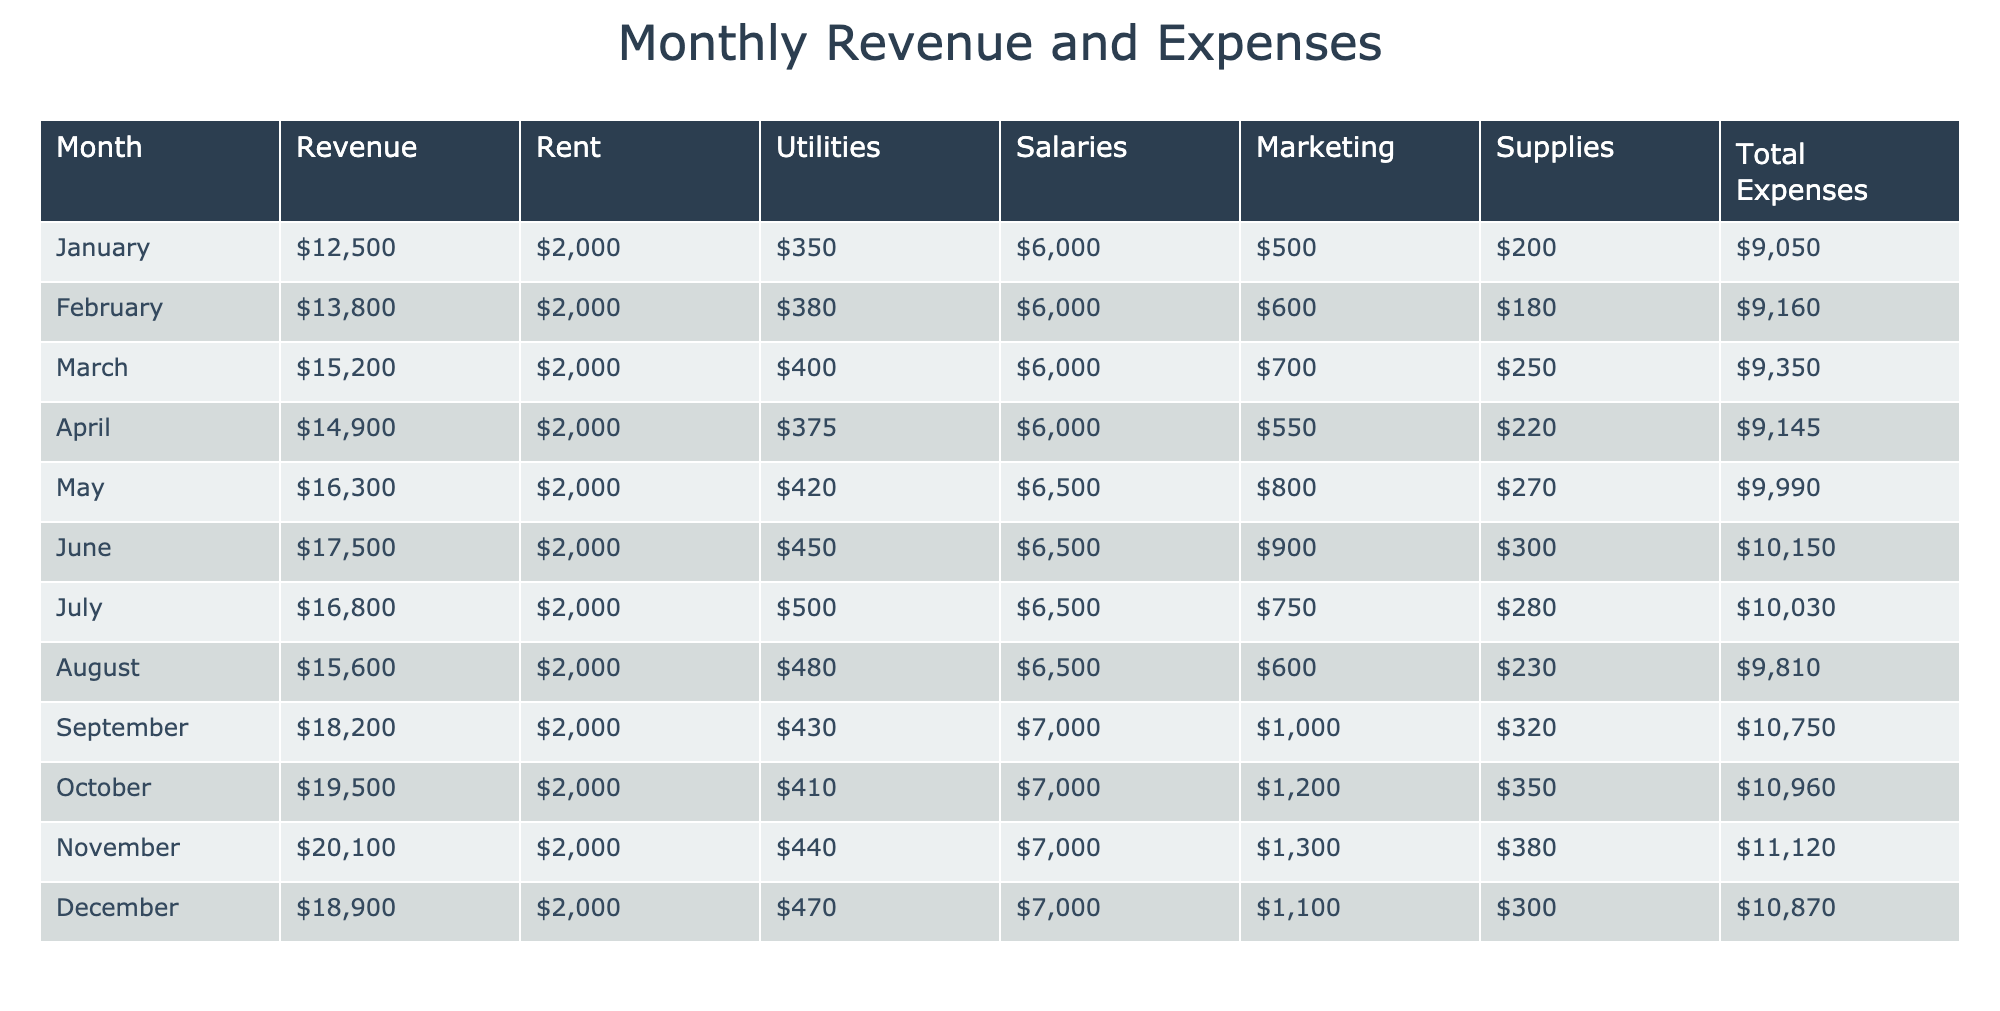What was the total revenue for April? In the table, I can locate the row for April, where the revenue amount is shown. According to the data presented, the total revenue for April is listed as $14,900.
Answer: $14,900 What are the total expenses for the counseling center in February? By examining the row for February, I find that the total expenses are provided directly. The total expenses for February are noted as $9,160.
Answer: $9,160 Which month had the highest revenue, and what was that amount? I can review each row to find the highest revenue figure. Scanning through the revenues listed from January to December, I see that December has the highest revenue of $18,900.
Answer: December, $18,900 What is the average total expenses for the counseling center across all months? To find the average total expenses, I need to sum the total expenses from each month and then divide by 12 (the total number of months). Total expenses sum up to $110,850, and dividing by 12 gives an average of $9,237.50.
Answer: $9,237.50 Did the total expenses increase or decrease from May to June? Looking at the total expenses for May ($9,990) and June ($10,150), I can conclude that the total expenses increased from May to June, as $10,150 is greater than $9,990.
Answer: Yes, increased Was the rent the same amount each month? Checking the rent figures across each month, I can see that the rent for the counseling center is consistently $2,000 every month. Thus, the rent is indeed the same.
Answer: Yes Which month had the lowest total expenses and what was that amount? By reviewing all total expenses, I can find the month with the minimum value. From the data, it is clear that February, with a total expense of $9,160, had the lowest expenses.
Answer: February, $9,160 How much more did the counseling center spend on marketing in November compared to January? For November, the marketing costs are $1,300, while for January they are $500. The difference is found by subtracting January's marketing costs from November's: $1,300 - $500 = $800.
Answer: $800 more Is it true that the total revenue exceeded the total expenses in every month? To verify this, I need to check the revenue and total expenses for each month. Since all months show higher revenues than total expenses, the statement is true.
Answer: Yes, true If we look at the highest revenue month, how much was spent on salaries? The month with the highest revenue is December at $18,900. Referring to the same row, the salaries for December amount to $7,000.
Answer: $7,000 